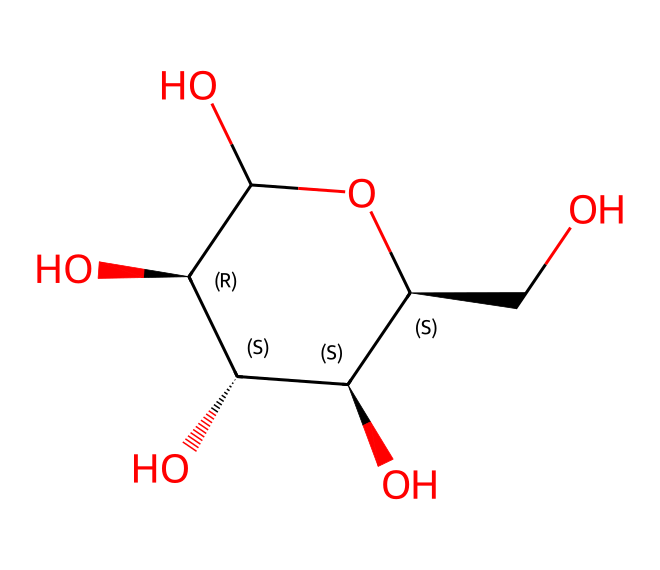What is the number of carbon atoms in the structure? To find the number of carbon atoms, we examine the SMILES representation, counting each 'C'. In this case, there are 6 carbon atoms in the backbone as identified visually in the structure.
Answer: 6 How many hydroxyl groups (-OH) are present? The structure includes multiple hydroxyl groups, identifiable by the 'O' in the structure connected to 'C'. Counting these in the visual shows there are 3 hydroxyl groups attached to the carbons.
Answer: 3 What type of polysaccharide does this structure represent? The structure is representative of cellulose, which is a polymer of glucose units. Focusing on the repetitive structure and connections helps identify it as cellulose.
Answer: cellulose Is the overall structure of the chemical branched or linear? The visual inspection of the SMILES shows a chain with no branched side chains, indicating a straight structure formed by linear polymerization of glucose units.
Answer: linear What functional group predominates in this structure? The -OH functional groups dominate the structure as observed in the chemical, making it hydrophilic. Their presence allows it to form hydrogen bonds, impacting its properties.
Answer: hydroxyl How does the structure contribute to its mechanical properties? The long linear chains and hydrogen bonds formed between the -OH groups provide strength and rigidity, which are critical for high-performance material applications typical of cellulose fibers.
Answer: hydrogen bonds 